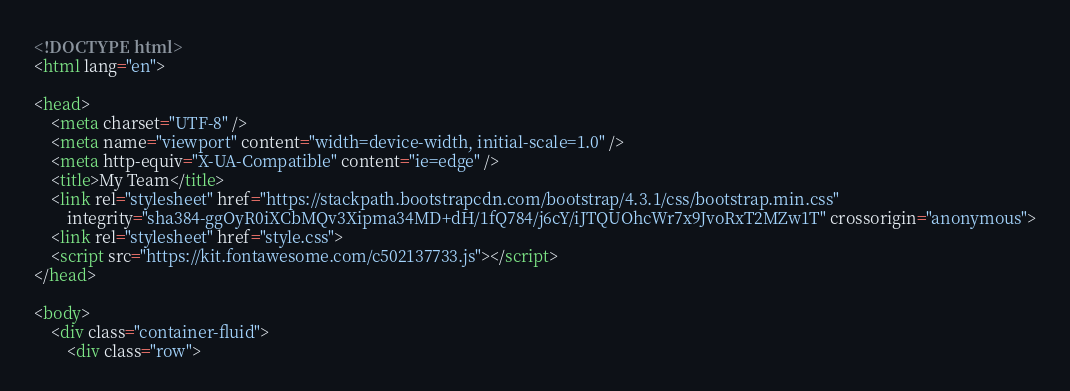<code> <loc_0><loc_0><loc_500><loc_500><_HTML_><!DOCTYPE html>
<html lang="en">

<head>
    <meta charset="UTF-8" />
    <meta name="viewport" content="width=device-width, initial-scale=1.0" />
    <meta http-equiv="X-UA-Compatible" content="ie=edge" />
    <title>My Team</title>
    <link rel="stylesheet" href="https://stackpath.bootstrapcdn.com/bootstrap/4.3.1/css/bootstrap.min.css"
        integrity="sha384-ggOyR0iXCbMQv3Xipma34MD+dH/1fQ784/j6cY/iJTQUOhcWr7x9JvoRxT2MZw1T" crossorigin="anonymous">
    <link rel="stylesheet" href="style.css">
    <script src="https://kit.fontawesome.com/c502137733.js"></script>
</head>

<body>
    <div class="container-fluid">
        <div class="row"></code> 